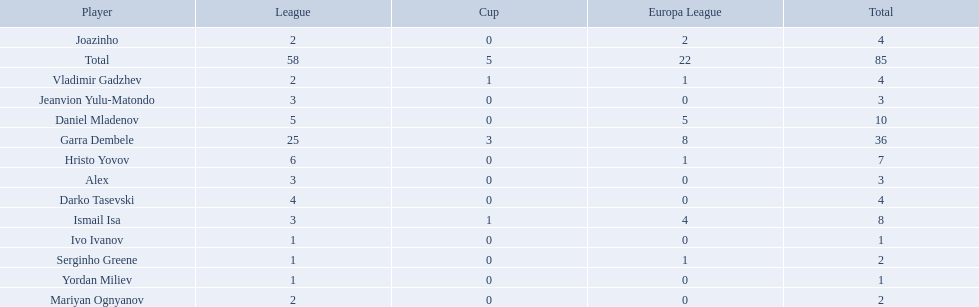What players did not score in all 3 competitions? Daniel Mladenov, Hristo Yovov, Joazinho, Darko Tasevski, Alex, Jeanvion Yulu-Matondo, Mariyan Ognyanov, Serginho Greene, Yordan Miliev, Ivo Ivanov. Which of those did not have total more then 5? Darko Tasevski, Alex, Jeanvion Yulu-Matondo, Mariyan Ognyanov, Serginho Greene, Yordan Miliev, Ivo Ivanov. Which ones scored more then 1 total? Darko Tasevski, Alex, Jeanvion Yulu-Matondo, Mariyan Ognyanov. Which of these player had the lease league points? Mariyan Ognyanov. 